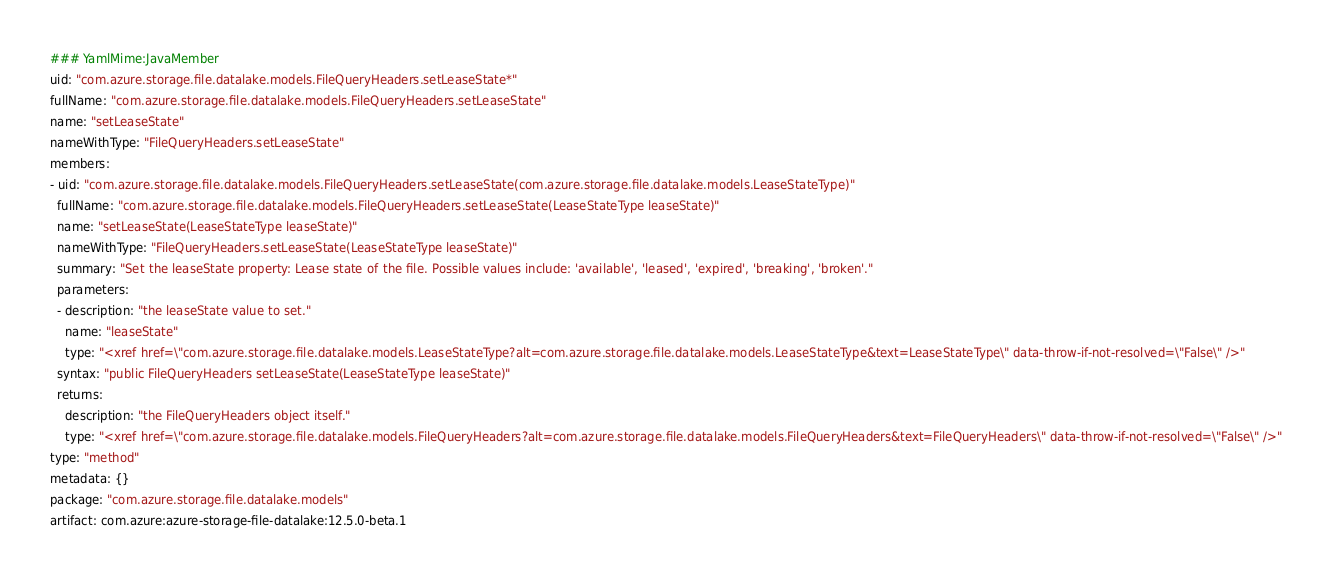<code> <loc_0><loc_0><loc_500><loc_500><_YAML_>### YamlMime:JavaMember
uid: "com.azure.storage.file.datalake.models.FileQueryHeaders.setLeaseState*"
fullName: "com.azure.storage.file.datalake.models.FileQueryHeaders.setLeaseState"
name: "setLeaseState"
nameWithType: "FileQueryHeaders.setLeaseState"
members:
- uid: "com.azure.storage.file.datalake.models.FileQueryHeaders.setLeaseState(com.azure.storage.file.datalake.models.LeaseStateType)"
  fullName: "com.azure.storage.file.datalake.models.FileQueryHeaders.setLeaseState(LeaseStateType leaseState)"
  name: "setLeaseState(LeaseStateType leaseState)"
  nameWithType: "FileQueryHeaders.setLeaseState(LeaseStateType leaseState)"
  summary: "Set the leaseState property: Lease state of the file. Possible values include: 'available', 'leased', 'expired', 'breaking', 'broken'."
  parameters:
  - description: "the leaseState value to set."
    name: "leaseState"
    type: "<xref href=\"com.azure.storage.file.datalake.models.LeaseStateType?alt=com.azure.storage.file.datalake.models.LeaseStateType&text=LeaseStateType\" data-throw-if-not-resolved=\"False\" />"
  syntax: "public FileQueryHeaders setLeaseState(LeaseStateType leaseState)"
  returns:
    description: "the FileQueryHeaders object itself."
    type: "<xref href=\"com.azure.storage.file.datalake.models.FileQueryHeaders?alt=com.azure.storage.file.datalake.models.FileQueryHeaders&text=FileQueryHeaders\" data-throw-if-not-resolved=\"False\" />"
type: "method"
metadata: {}
package: "com.azure.storage.file.datalake.models"
artifact: com.azure:azure-storage-file-datalake:12.5.0-beta.1
</code> 